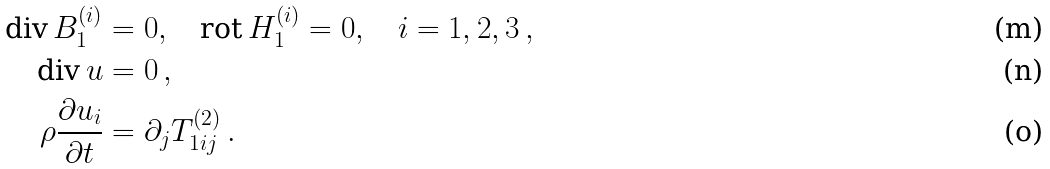Convert formula to latex. <formula><loc_0><loc_0><loc_500><loc_500>\text {div} \, B _ { 1 } ^ { ( i ) } & = 0 , \quad \text {rot} \, H _ { 1 } ^ { ( i ) } = 0 , \quad i = 1 , 2 , 3 \, , \\ \text {div} \, u & = 0 \, , \\ \rho \frac { \partial u _ { i } } { \partial t } & = \partial _ { j } T _ { 1 i j } ^ { ( 2 ) } \, .</formula> 